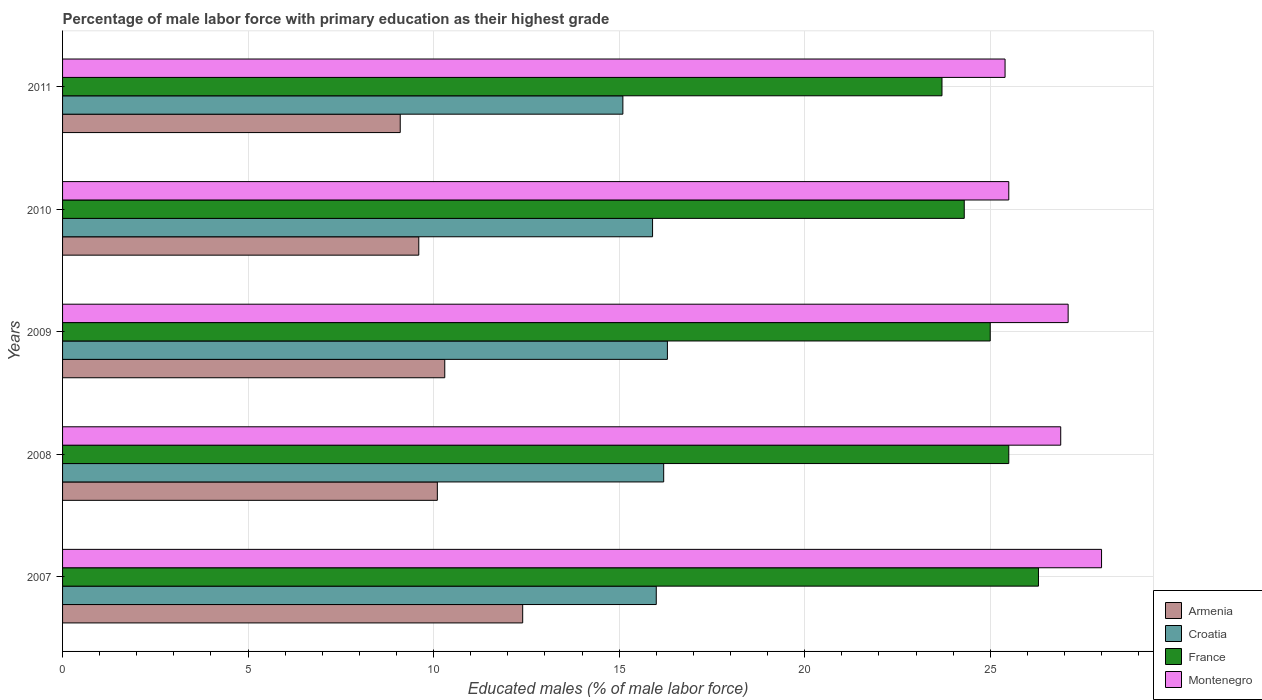How many groups of bars are there?
Ensure brevity in your answer.  5. Are the number of bars on each tick of the Y-axis equal?
Ensure brevity in your answer.  Yes. What is the label of the 5th group of bars from the top?
Provide a succinct answer. 2007. In how many cases, is the number of bars for a given year not equal to the number of legend labels?
Your response must be concise. 0. Across all years, what is the maximum percentage of male labor force with primary education in Montenegro?
Provide a succinct answer. 28. Across all years, what is the minimum percentage of male labor force with primary education in France?
Ensure brevity in your answer.  23.7. In which year was the percentage of male labor force with primary education in Montenegro minimum?
Provide a succinct answer. 2011. What is the total percentage of male labor force with primary education in Montenegro in the graph?
Provide a short and direct response. 132.9. What is the difference between the percentage of male labor force with primary education in Armenia in 2008 and that in 2011?
Your response must be concise. 1. What is the difference between the percentage of male labor force with primary education in Armenia in 2008 and the percentage of male labor force with primary education in France in 2007?
Provide a short and direct response. -16.2. What is the average percentage of male labor force with primary education in Montenegro per year?
Offer a terse response. 26.58. In the year 2010, what is the difference between the percentage of male labor force with primary education in Montenegro and percentage of male labor force with primary education in France?
Make the answer very short. 1.2. In how many years, is the percentage of male labor force with primary education in Croatia greater than 2 %?
Your answer should be very brief. 5. What is the ratio of the percentage of male labor force with primary education in France in 2009 to that in 2010?
Offer a very short reply. 1.03. Is the percentage of male labor force with primary education in France in 2010 less than that in 2011?
Provide a succinct answer. No. Is the difference between the percentage of male labor force with primary education in Montenegro in 2007 and 2009 greater than the difference between the percentage of male labor force with primary education in France in 2007 and 2009?
Offer a terse response. No. What is the difference between the highest and the second highest percentage of male labor force with primary education in Armenia?
Provide a succinct answer. 2.1. What is the difference between the highest and the lowest percentage of male labor force with primary education in Armenia?
Offer a terse response. 3.3. In how many years, is the percentage of male labor force with primary education in Armenia greater than the average percentage of male labor force with primary education in Armenia taken over all years?
Provide a short and direct response. 2. What does the 1st bar from the top in 2011 represents?
Provide a short and direct response. Montenegro. What does the 2nd bar from the bottom in 2011 represents?
Provide a succinct answer. Croatia. How many bars are there?
Keep it short and to the point. 20. What is the difference between two consecutive major ticks on the X-axis?
Offer a terse response. 5. Are the values on the major ticks of X-axis written in scientific E-notation?
Make the answer very short. No. Does the graph contain any zero values?
Your answer should be very brief. No. What is the title of the graph?
Provide a short and direct response. Percentage of male labor force with primary education as their highest grade. Does "Finland" appear as one of the legend labels in the graph?
Offer a very short reply. No. What is the label or title of the X-axis?
Your response must be concise. Educated males (% of male labor force). What is the label or title of the Y-axis?
Your response must be concise. Years. What is the Educated males (% of male labor force) of Armenia in 2007?
Your answer should be very brief. 12.4. What is the Educated males (% of male labor force) in Croatia in 2007?
Offer a terse response. 16. What is the Educated males (% of male labor force) of France in 2007?
Your answer should be compact. 26.3. What is the Educated males (% of male labor force) in Armenia in 2008?
Your answer should be compact. 10.1. What is the Educated males (% of male labor force) of Croatia in 2008?
Your answer should be very brief. 16.2. What is the Educated males (% of male labor force) of France in 2008?
Your response must be concise. 25.5. What is the Educated males (% of male labor force) in Montenegro in 2008?
Your response must be concise. 26.9. What is the Educated males (% of male labor force) of Armenia in 2009?
Provide a short and direct response. 10.3. What is the Educated males (% of male labor force) in Croatia in 2009?
Offer a terse response. 16.3. What is the Educated males (% of male labor force) in France in 2009?
Make the answer very short. 25. What is the Educated males (% of male labor force) of Montenegro in 2009?
Provide a short and direct response. 27.1. What is the Educated males (% of male labor force) in Armenia in 2010?
Your response must be concise. 9.6. What is the Educated males (% of male labor force) of Croatia in 2010?
Provide a short and direct response. 15.9. What is the Educated males (% of male labor force) in France in 2010?
Make the answer very short. 24.3. What is the Educated males (% of male labor force) in Montenegro in 2010?
Provide a short and direct response. 25.5. What is the Educated males (% of male labor force) of Armenia in 2011?
Your answer should be very brief. 9.1. What is the Educated males (% of male labor force) of Croatia in 2011?
Provide a short and direct response. 15.1. What is the Educated males (% of male labor force) of France in 2011?
Your response must be concise. 23.7. What is the Educated males (% of male labor force) of Montenegro in 2011?
Ensure brevity in your answer.  25.4. Across all years, what is the maximum Educated males (% of male labor force) in Armenia?
Ensure brevity in your answer.  12.4. Across all years, what is the maximum Educated males (% of male labor force) in Croatia?
Offer a very short reply. 16.3. Across all years, what is the maximum Educated males (% of male labor force) of France?
Your answer should be compact. 26.3. Across all years, what is the minimum Educated males (% of male labor force) in Armenia?
Provide a short and direct response. 9.1. Across all years, what is the minimum Educated males (% of male labor force) in Croatia?
Offer a very short reply. 15.1. Across all years, what is the minimum Educated males (% of male labor force) of France?
Provide a succinct answer. 23.7. Across all years, what is the minimum Educated males (% of male labor force) of Montenegro?
Provide a succinct answer. 25.4. What is the total Educated males (% of male labor force) of Armenia in the graph?
Your answer should be compact. 51.5. What is the total Educated males (% of male labor force) of Croatia in the graph?
Provide a succinct answer. 79.5. What is the total Educated males (% of male labor force) of France in the graph?
Your answer should be compact. 124.8. What is the total Educated males (% of male labor force) in Montenegro in the graph?
Your response must be concise. 132.9. What is the difference between the Educated males (% of male labor force) in Armenia in 2007 and that in 2008?
Keep it short and to the point. 2.3. What is the difference between the Educated males (% of male labor force) in France in 2007 and that in 2008?
Offer a terse response. 0.8. What is the difference between the Educated males (% of male labor force) of Croatia in 2007 and that in 2009?
Offer a very short reply. -0.3. What is the difference between the Educated males (% of male labor force) of Montenegro in 2007 and that in 2009?
Keep it short and to the point. 0.9. What is the difference between the Educated males (% of male labor force) of Croatia in 2007 and that in 2010?
Provide a short and direct response. 0.1. What is the difference between the Educated males (% of male labor force) in Armenia in 2007 and that in 2011?
Your answer should be very brief. 3.3. What is the difference between the Educated males (% of male labor force) in Croatia in 2007 and that in 2011?
Your answer should be very brief. 0.9. What is the difference between the Educated males (% of male labor force) of Montenegro in 2007 and that in 2011?
Ensure brevity in your answer.  2.6. What is the difference between the Educated males (% of male labor force) in Armenia in 2008 and that in 2009?
Provide a short and direct response. -0.2. What is the difference between the Educated males (% of male labor force) of Croatia in 2008 and that in 2009?
Keep it short and to the point. -0.1. What is the difference between the Educated males (% of male labor force) in France in 2008 and that in 2009?
Make the answer very short. 0.5. What is the difference between the Educated males (% of male labor force) in Montenegro in 2008 and that in 2009?
Provide a short and direct response. -0.2. What is the difference between the Educated males (% of male labor force) of Croatia in 2008 and that in 2010?
Make the answer very short. 0.3. What is the difference between the Educated males (% of male labor force) in Armenia in 2008 and that in 2011?
Provide a short and direct response. 1. What is the difference between the Educated males (% of male labor force) of France in 2008 and that in 2011?
Give a very brief answer. 1.8. What is the difference between the Educated males (% of male labor force) of Croatia in 2009 and that in 2010?
Ensure brevity in your answer.  0.4. What is the difference between the Educated males (% of male labor force) in France in 2009 and that in 2010?
Offer a very short reply. 0.7. What is the difference between the Educated males (% of male labor force) in Montenegro in 2009 and that in 2011?
Provide a short and direct response. 1.7. What is the difference between the Educated males (% of male labor force) in Croatia in 2010 and that in 2011?
Make the answer very short. 0.8. What is the difference between the Educated males (% of male labor force) of Montenegro in 2010 and that in 2011?
Your answer should be very brief. 0.1. What is the difference between the Educated males (% of male labor force) of Armenia in 2007 and the Educated males (% of male labor force) of Croatia in 2008?
Offer a terse response. -3.8. What is the difference between the Educated males (% of male labor force) of Armenia in 2007 and the Educated males (% of male labor force) of France in 2008?
Give a very brief answer. -13.1. What is the difference between the Educated males (% of male labor force) in Croatia in 2007 and the Educated males (% of male labor force) in Montenegro in 2008?
Keep it short and to the point. -10.9. What is the difference between the Educated males (% of male labor force) in France in 2007 and the Educated males (% of male labor force) in Montenegro in 2008?
Your answer should be compact. -0.6. What is the difference between the Educated males (% of male labor force) in Armenia in 2007 and the Educated males (% of male labor force) in Croatia in 2009?
Offer a very short reply. -3.9. What is the difference between the Educated males (% of male labor force) in Armenia in 2007 and the Educated males (% of male labor force) in France in 2009?
Your answer should be compact. -12.6. What is the difference between the Educated males (% of male labor force) in Armenia in 2007 and the Educated males (% of male labor force) in Montenegro in 2009?
Your response must be concise. -14.7. What is the difference between the Educated males (% of male labor force) of Croatia in 2007 and the Educated males (% of male labor force) of France in 2009?
Offer a very short reply. -9. What is the difference between the Educated males (% of male labor force) of France in 2007 and the Educated males (% of male labor force) of Montenegro in 2009?
Offer a terse response. -0.8. What is the difference between the Educated males (% of male labor force) of Armenia in 2007 and the Educated males (% of male labor force) of Montenegro in 2010?
Your answer should be compact. -13.1. What is the difference between the Educated males (% of male labor force) of Croatia in 2007 and the Educated males (% of male labor force) of France in 2010?
Your answer should be very brief. -8.3. What is the difference between the Educated males (% of male labor force) in Armenia in 2007 and the Educated males (% of male labor force) in France in 2011?
Provide a short and direct response. -11.3. What is the difference between the Educated males (% of male labor force) of Croatia in 2007 and the Educated males (% of male labor force) of Montenegro in 2011?
Provide a short and direct response. -9.4. What is the difference between the Educated males (% of male labor force) in France in 2007 and the Educated males (% of male labor force) in Montenegro in 2011?
Keep it short and to the point. 0.9. What is the difference between the Educated males (% of male labor force) in Armenia in 2008 and the Educated males (% of male labor force) in Croatia in 2009?
Keep it short and to the point. -6.2. What is the difference between the Educated males (% of male labor force) in Armenia in 2008 and the Educated males (% of male labor force) in France in 2009?
Offer a very short reply. -14.9. What is the difference between the Educated males (% of male labor force) in Croatia in 2008 and the Educated males (% of male labor force) in Montenegro in 2009?
Your answer should be very brief. -10.9. What is the difference between the Educated males (% of male labor force) in Armenia in 2008 and the Educated males (% of male labor force) in Croatia in 2010?
Your answer should be very brief. -5.8. What is the difference between the Educated males (% of male labor force) of Armenia in 2008 and the Educated males (% of male labor force) of Montenegro in 2010?
Provide a succinct answer. -15.4. What is the difference between the Educated males (% of male labor force) of Armenia in 2008 and the Educated males (% of male labor force) of Croatia in 2011?
Provide a succinct answer. -5. What is the difference between the Educated males (% of male labor force) of Armenia in 2008 and the Educated males (% of male labor force) of Montenegro in 2011?
Give a very brief answer. -15.3. What is the difference between the Educated males (% of male labor force) of Croatia in 2008 and the Educated males (% of male labor force) of France in 2011?
Your answer should be very brief. -7.5. What is the difference between the Educated males (% of male labor force) in Croatia in 2008 and the Educated males (% of male labor force) in Montenegro in 2011?
Provide a short and direct response. -9.2. What is the difference between the Educated males (% of male labor force) in France in 2008 and the Educated males (% of male labor force) in Montenegro in 2011?
Offer a very short reply. 0.1. What is the difference between the Educated males (% of male labor force) in Armenia in 2009 and the Educated males (% of male labor force) in Croatia in 2010?
Provide a short and direct response. -5.6. What is the difference between the Educated males (% of male labor force) in Armenia in 2009 and the Educated males (% of male labor force) in France in 2010?
Provide a succinct answer. -14. What is the difference between the Educated males (% of male labor force) in Armenia in 2009 and the Educated males (% of male labor force) in Montenegro in 2010?
Provide a short and direct response. -15.2. What is the difference between the Educated males (% of male labor force) in Croatia in 2009 and the Educated males (% of male labor force) in France in 2010?
Make the answer very short. -8. What is the difference between the Educated males (% of male labor force) in Armenia in 2009 and the Educated males (% of male labor force) in Montenegro in 2011?
Give a very brief answer. -15.1. What is the difference between the Educated males (% of male labor force) in Armenia in 2010 and the Educated males (% of male labor force) in France in 2011?
Keep it short and to the point. -14.1. What is the difference between the Educated males (% of male labor force) in Armenia in 2010 and the Educated males (% of male labor force) in Montenegro in 2011?
Your answer should be compact. -15.8. What is the average Educated males (% of male labor force) of Croatia per year?
Offer a very short reply. 15.9. What is the average Educated males (% of male labor force) of France per year?
Your answer should be very brief. 24.96. What is the average Educated males (% of male labor force) of Montenegro per year?
Provide a short and direct response. 26.58. In the year 2007, what is the difference between the Educated males (% of male labor force) in Armenia and Educated males (% of male labor force) in France?
Ensure brevity in your answer.  -13.9. In the year 2007, what is the difference between the Educated males (% of male labor force) in Armenia and Educated males (% of male labor force) in Montenegro?
Make the answer very short. -15.6. In the year 2007, what is the difference between the Educated males (% of male labor force) of Croatia and Educated males (% of male labor force) of Montenegro?
Offer a very short reply. -12. In the year 2008, what is the difference between the Educated males (% of male labor force) of Armenia and Educated males (% of male labor force) of France?
Your answer should be compact. -15.4. In the year 2008, what is the difference between the Educated males (% of male labor force) in Armenia and Educated males (% of male labor force) in Montenegro?
Your answer should be very brief. -16.8. In the year 2008, what is the difference between the Educated males (% of male labor force) in Croatia and Educated males (% of male labor force) in Montenegro?
Ensure brevity in your answer.  -10.7. In the year 2008, what is the difference between the Educated males (% of male labor force) of France and Educated males (% of male labor force) of Montenegro?
Ensure brevity in your answer.  -1.4. In the year 2009, what is the difference between the Educated males (% of male labor force) in Armenia and Educated males (% of male labor force) in Croatia?
Make the answer very short. -6. In the year 2009, what is the difference between the Educated males (% of male labor force) in Armenia and Educated males (% of male labor force) in France?
Your answer should be very brief. -14.7. In the year 2009, what is the difference between the Educated males (% of male labor force) in Armenia and Educated males (% of male labor force) in Montenegro?
Your answer should be compact. -16.8. In the year 2009, what is the difference between the Educated males (% of male labor force) in Croatia and Educated males (% of male labor force) in Montenegro?
Ensure brevity in your answer.  -10.8. In the year 2010, what is the difference between the Educated males (% of male labor force) of Armenia and Educated males (% of male labor force) of France?
Give a very brief answer. -14.7. In the year 2010, what is the difference between the Educated males (% of male labor force) of Armenia and Educated males (% of male labor force) of Montenegro?
Offer a terse response. -15.9. In the year 2010, what is the difference between the Educated males (% of male labor force) in Croatia and Educated males (% of male labor force) in France?
Make the answer very short. -8.4. In the year 2010, what is the difference between the Educated males (% of male labor force) of Croatia and Educated males (% of male labor force) of Montenegro?
Keep it short and to the point. -9.6. In the year 2010, what is the difference between the Educated males (% of male labor force) of France and Educated males (% of male labor force) of Montenegro?
Give a very brief answer. -1.2. In the year 2011, what is the difference between the Educated males (% of male labor force) of Armenia and Educated males (% of male labor force) of Croatia?
Give a very brief answer. -6. In the year 2011, what is the difference between the Educated males (% of male labor force) of Armenia and Educated males (% of male labor force) of France?
Give a very brief answer. -14.6. In the year 2011, what is the difference between the Educated males (% of male labor force) in Armenia and Educated males (% of male labor force) in Montenegro?
Ensure brevity in your answer.  -16.3. What is the ratio of the Educated males (% of male labor force) of Armenia in 2007 to that in 2008?
Keep it short and to the point. 1.23. What is the ratio of the Educated males (% of male labor force) in France in 2007 to that in 2008?
Make the answer very short. 1.03. What is the ratio of the Educated males (% of male labor force) in Montenegro in 2007 to that in 2008?
Offer a terse response. 1.04. What is the ratio of the Educated males (% of male labor force) in Armenia in 2007 to that in 2009?
Provide a short and direct response. 1.2. What is the ratio of the Educated males (% of male labor force) in Croatia in 2007 to that in 2009?
Give a very brief answer. 0.98. What is the ratio of the Educated males (% of male labor force) in France in 2007 to that in 2009?
Your answer should be very brief. 1.05. What is the ratio of the Educated males (% of male labor force) in Montenegro in 2007 to that in 2009?
Provide a short and direct response. 1.03. What is the ratio of the Educated males (% of male labor force) in Armenia in 2007 to that in 2010?
Your response must be concise. 1.29. What is the ratio of the Educated males (% of male labor force) in Croatia in 2007 to that in 2010?
Your response must be concise. 1.01. What is the ratio of the Educated males (% of male labor force) in France in 2007 to that in 2010?
Your answer should be compact. 1.08. What is the ratio of the Educated males (% of male labor force) in Montenegro in 2007 to that in 2010?
Offer a very short reply. 1.1. What is the ratio of the Educated males (% of male labor force) of Armenia in 2007 to that in 2011?
Provide a succinct answer. 1.36. What is the ratio of the Educated males (% of male labor force) in Croatia in 2007 to that in 2011?
Keep it short and to the point. 1.06. What is the ratio of the Educated males (% of male labor force) of France in 2007 to that in 2011?
Offer a terse response. 1.11. What is the ratio of the Educated males (% of male labor force) of Montenegro in 2007 to that in 2011?
Your answer should be very brief. 1.1. What is the ratio of the Educated males (% of male labor force) of Armenia in 2008 to that in 2009?
Provide a short and direct response. 0.98. What is the ratio of the Educated males (% of male labor force) in Croatia in 2008 to that in 2009?
Give a very brief answer. 0.99. What is the ratio of the Educated males (% of male labor force) of France in 2008 to that in 2009?
Keep it short and to the point. 1.02. What is the ratio of the Educated males (% of male labor force) of Armenia in 2008 to that in 2010?
Your response must be concise. 1.05. What is the ratio of the Educated males (% of male labor force) in Croatia in 2008 to that in 2010?
Make the answer very short. 1.02. What is the ratio of the Educated males (% of male labor force) in France in 2008 to that in 2010?
Offer a very short reply. 1.05. What is the ratio of the Educated males (% of male labor force) of Montenegro in 2008 to that in 2010?
Your response must be concise. 1.05. What is the ratio of the Educated males (% of male labor force) in Armenia in 2008 to that in 2011?
Provide a succinct answer. 1.11. What is the ratio of the Educated males (% of male labor force) of Croatia in 2008 to that in 2011?
Ensure brevity in your answer.  1.07. What is the ratio of the Educated males (% of male labor force) of France in 2008 to that in 2011?
Your answer should be compact. 1.08. What is the ratio of the Educated males (% of male labor force) in Montenegro in 2008 to that in 2011?
Provide a succinct answer. 1.06. What is the ratio of the Educated males (% of male labor force) of Armenia in 2009 to that in 2010?
Give a very brief answer. 1.07. What is the ratio of the Educated males (% of male labor force) of Croatia in 2009 to that in 2010?
Offer a very short reply. 1.03. What is the ratio of the Educated males (% of male labor force) of France in 2009 to that in 2010?
Keep it short and to the point. 1.03. What is the ratio of the Educated males (% of male labor force) of Montenegro in 2009 to that in 2010?
Ensure brevity in your answer.  1.06. What is the ratio of the Educated males (% of male labor force) in Armenia in 2009 to that in 2011?
Provide a short and direct response. 1.13. What is the ratio of the Educated males (% of male labor force) of Croatia in 2009 to that in 2011?
Make the answer very short. 1.08. What is the ratio of the Educated males (% of male labor force) of France in 2009 to that in 2011?
Provide a succinct answer. 1.05. What is the ratio of the Educated males (% of male labor force) in Montenegro in 2009 to that in 2011?
Give a very brief answer. 1.07. What is the ratio of the Educated males (% of male labor force) of Armenia in 2010 to that in 2011?
Provide a succinct answer. 1.05. What is the ratio of the Educated males (% of male labor force) of Croatia in 2010 to that in 2011?
Provide a succinct answer. 1.05. What is the ratio of the Educated males (% of male labor force) in France in 2010 to that in 2011?
Provide a succinct answer. 1.03. What is the difference between the highest and the second highest Educated males (% of male labor force) in France?
Offer a terse response. 0.8. What is the difference between the highest and the lowest Educated males (% of male labor force) of Armenia?
Offer a terse response. 3.3. What is the difference between the highest and the lowest Educated males (% of male labor force) of Croatia?
Ensure brevity in your answer.  1.2. What is the difference between the highest and the lowest Educated males (% of male labor force) in Montenegro?
Your answer should be very brief. 2.6. 